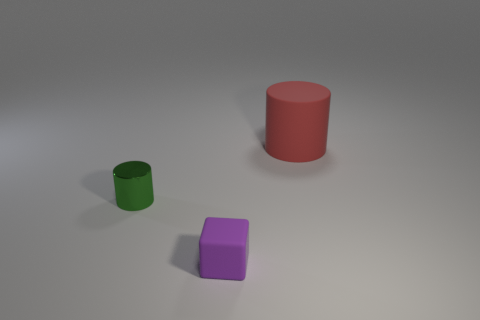Is there any other thing that is the same size as the red cylinder?
Your answer should be very brief. No. There is a rubber thing behind the green metallic object; how big is it?
Your answer should be very brief. Large. There is a cylinder that is to the right of the tiny thing in front of the metallic cylinder; how many large red cylinders are behind it?
Give a very brief answer. 0. Are there any small purple blocks in front of the large rubber thing?
Your answer should be compact. Yes. What number of other objects are there of the same size as the green thing?
Offer a terse response. 1. What is the material of the thing that is behind the tiny cube and left of the large red object?
Your answer should be very brief. Metal. There is a object that is behind the green shiny cylinder; is it the same shape as the tiny object behind the small purple matte cube?
Your answer should be very brief. Yes. Is there anything else that is made of the same material as the small green cylinder?
Offer a very short reply. No. What shape is the small object that is behind the tiny object to the right of the cylinder that is to the left of the red matte cylinder?
Your response must be concise. Cylinder. What number of other objects are the same shape as the tiny purple thing?
Ensure brevity in your answer.  0. 